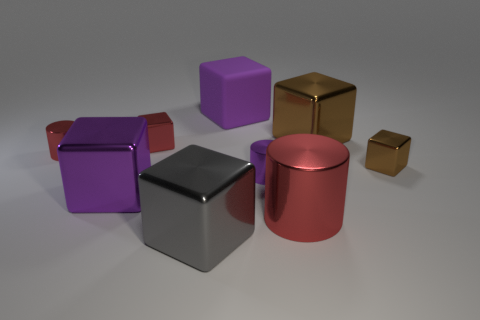Subtract all red blocks. How many blocks are left? 5 Subtract all large purple metallic blocks. How many blocks are left? 5 Subtract all blue blocks. Subtract all cyan balls. How many blocks are left? 6 Subtract all cubes. How many objects are left? 3 Add 5 gray metal objects. How many gray metal objects exist? 6 Subtract 0 purple spheres. How many objects are left? 9 Subtract all tiny brown metallic blocks. Subtract all red shiny cylinders. How many objects are left? 6 Add 3 small metallic cubes. How many small metallic cubes are left? 5 